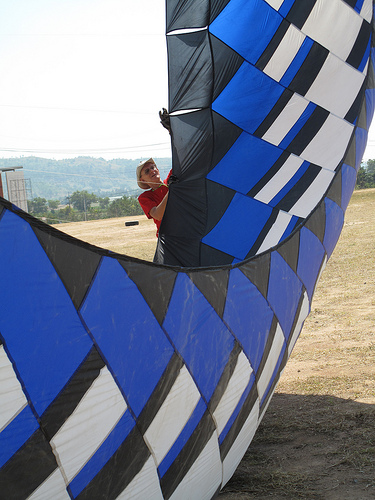<image>
Can you confirm if the man is in front of the flag? Yes. The man is positioned in front of the flag, appearing closer to the camera viewpoint. 